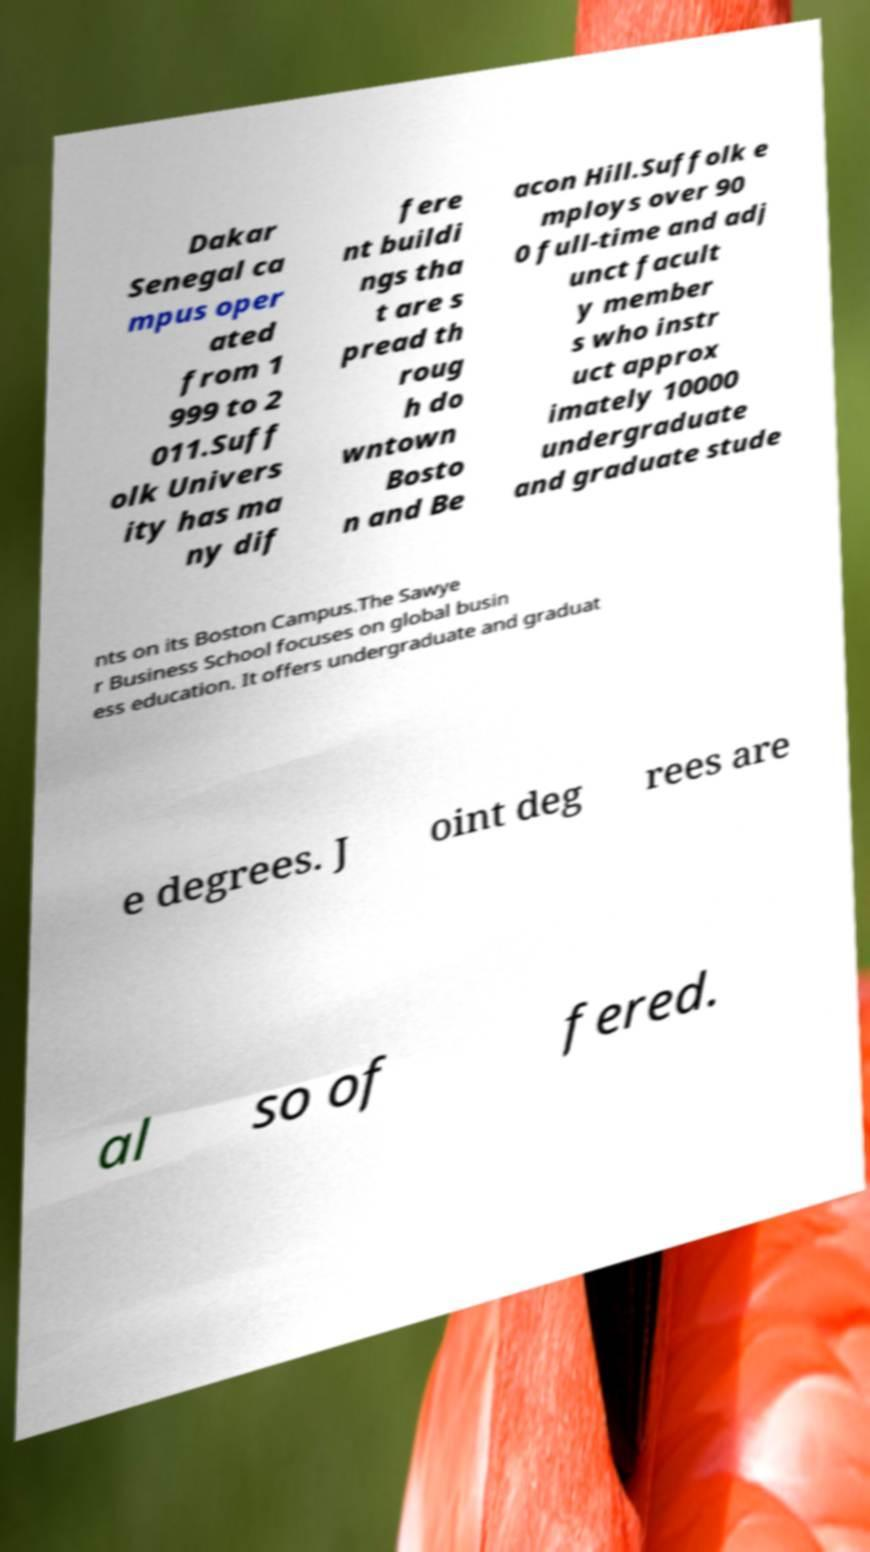Could you extract and type out the text from this image? Dakar Senegal ca mpus oper ated from 1 999 to 2 011.Suff olk Univers ity has ma ny dif fere nt buildi ngs tha t are s pread th roug h do wntown Bosto n and Be acon Hill.Suffolk e mploys over 90 0 full-time and adj unct facult y member s who instr uct approx imately 10000 undergraduate and graduate stude nts on its Boston Campus.The Sawye r Business School focuses on global busin ess education. It offers undergraduate and graduat e degrees. J oint deg rees are al so of fered. 